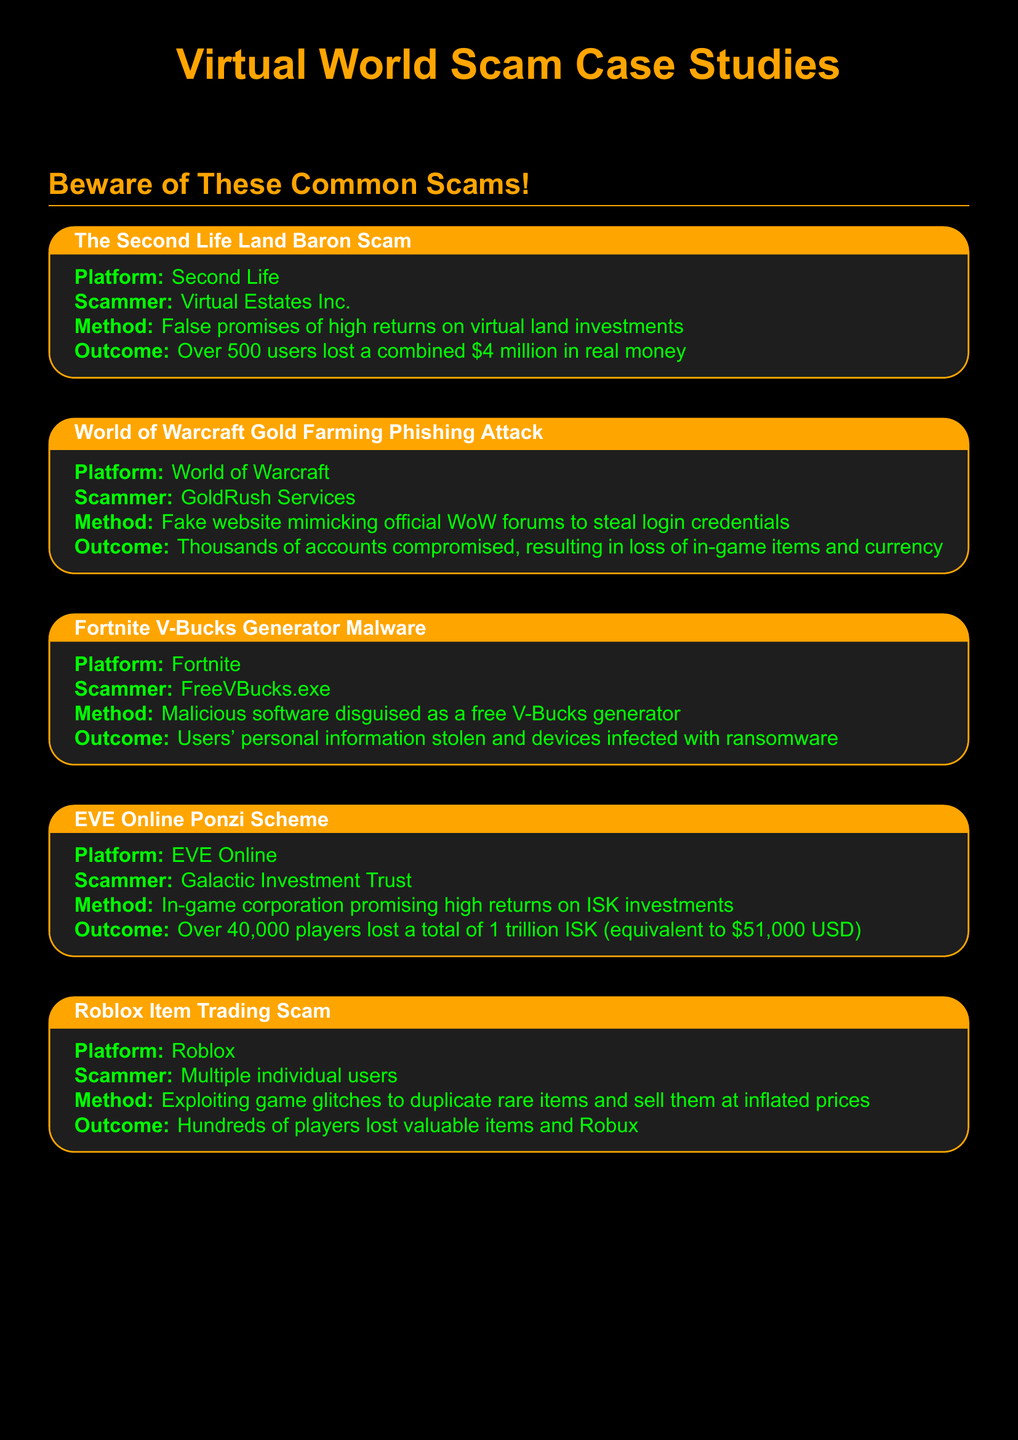What is the name of the scam in Second Life? The name of the scam involved in Second Life is specifically referred to as "The Second Life Land Baron Scam" in the document.
Answer: The Second Life Land Baron Scam How much money did users lose in the Second Life scam? The document states that over 500 users lost a combined total of $4 million in real money due to this scam.
Answer: $4 million Which platform was affected by the Fortnite V-Bucks generator malware? According to the document, the platform affected by the malware is Fortnite, as specified under the scam title.
Answer: Fortnite What method was used in the EVE Online Ponzi scheme? The method used in the EVE Online Ponzi scheme involved an in-game corporation promising high returns on ISK investments.
Answer: Promising high returns on ISK investments How many players lost money in the EVE Online Ponzi scheme? The document indicates that over 40,000 players lost money in the EVE Online Ponzi scheme, reflecting the scale of this scam.
Answer: Over 40,000 players What key lesson emphasizes caution against unofficial software? The key lesson mentioned in the document explicitly advises against downloading unofficial software promising free in-game currency, reflecting the need for caution.
Answer: Never download unofficial software promising free in-game currency What is the outcome of the Roblox item trading scam? The document notes that hundreds of players lost valuable items and Robux as a result of this scam, highlighting its impact on users.
Answer: Hundreds of players lost valuable items and Robux What color is used for the background in the document? The document specifies that the background color is set to a dark shade (black) using a custom RGB value that represents the intended style.
Answer: Black 